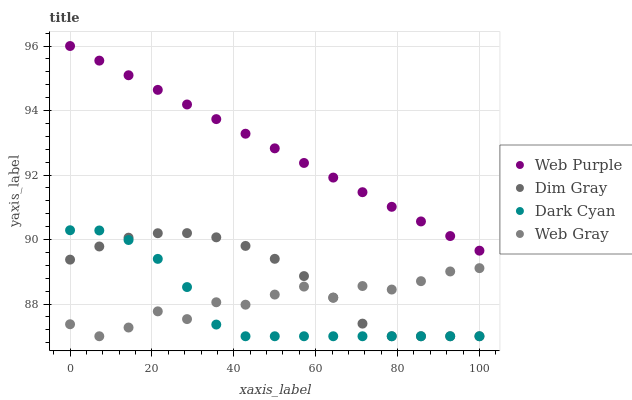Does Dark Cyan have the minimum area under the curve?
Answer yes or no. Yes. Does Web Purple have the maximum area under the curve?
Answer yes or no. Yes. Does Dim Gray have the minimum area under the curve?
Answer yes or no. No. Does Dim Gray have the maximum area under the curve?
Answer yes or no. No. Is Web Purple the smoothest?
Answer yes or no. Yes. Is Web Gray the roughest?
Answer yes or no. Yes. Is Dim Gray the smoothest?
Answer yes or no. No. Is Dim Gray the roughest?
Answer yes or no. No. Does Dark Cyan have the lowest value?
Answer yes or no. Yes. Does Web Purple have the lowest value?
Answer yes or no. No. Does Web Purple have the highest value?
Answer yes or no. Yes. Does Dim Gray have the highest value?
Answer yes or no. No. Is Dark Cyan less than Web Purple?
Answer yes or no. Yes. Is Web Purple greater than Dim Gray?
Answer yes or no. Yes. Does Web Gray intersect Dark Cyan?
Answer yes or no. Yes. Is Web Gray less than Dark Cyan?
Answer yes or no. No. Is Web Gray greater than Dark Cyan?
Answer yes or no. No. Does Dark Cyan intersect Web Purple?
Answer yes or no. No. 